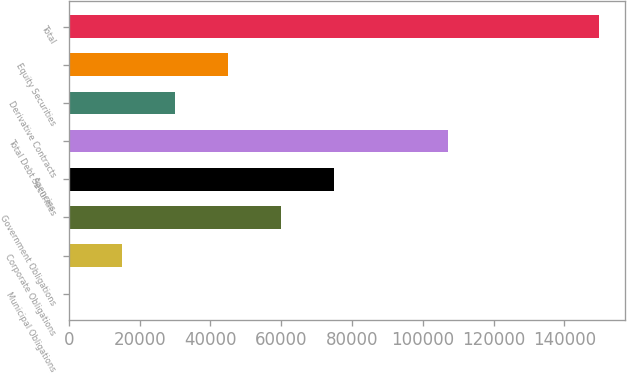Convert chart. <chart><loc_0><loc_0><loc_500><loc_500><bar_chart><fcel>Municipal Obligations<fcel>Corporate Obligations<fcel>Government Obligations<fcel>Agencies<fcel>Total Debt Securities<fcel>Derivative Contracts<fcel>Equity Securities<fcel>Total<nl><fcel>54<fcel>15021.5<fcel>59924<fcel>74891.5<fcel>107110<fcel>29989<fcel>44956.5<fcel>149729<nl></chart> 